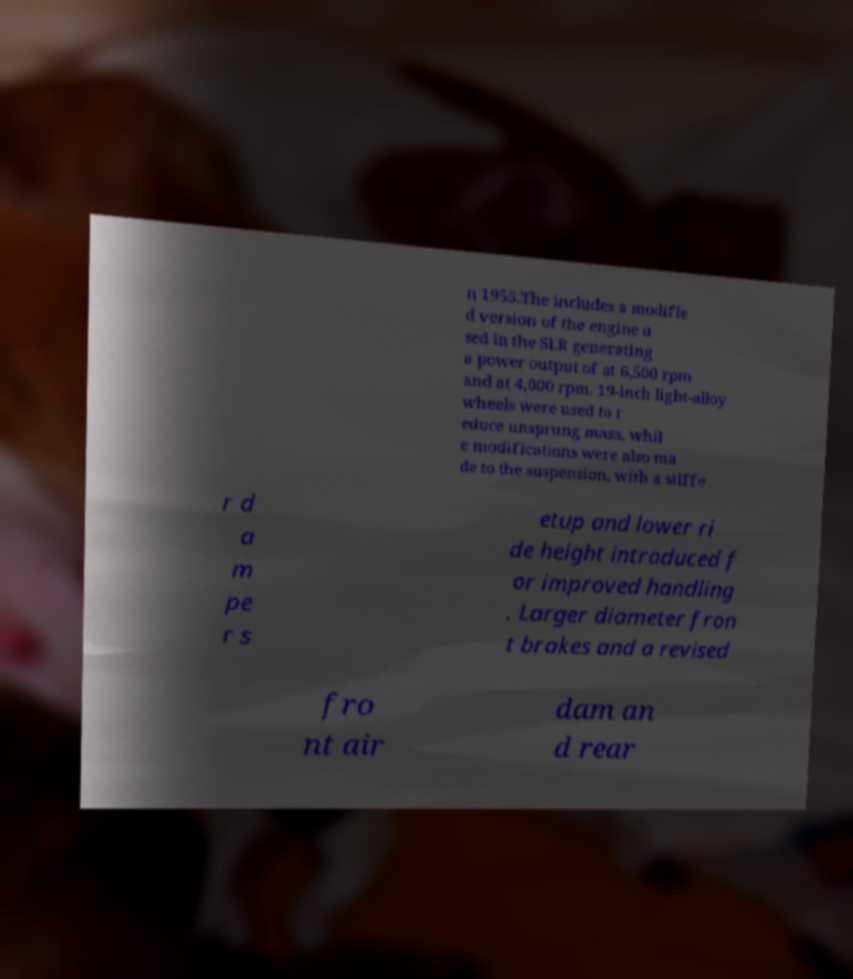There's text embedded in this image that I need extracted. Can you transcribe it verbatim? n 1955.The includes a modifie d version of the engine u sed in the SLR generating a power output of at 6,500 rpm and at 4,000 rpm. 19-inch light-alloy wheels were used to r educe unsprung mass, whil e modifications were also ma de to the suspension, with a stiffe r d a m pe r s etup and lower ri de height introduced f or improved handling . Larger diameter fron t brakes and a revised fro nt air dam an d rear 